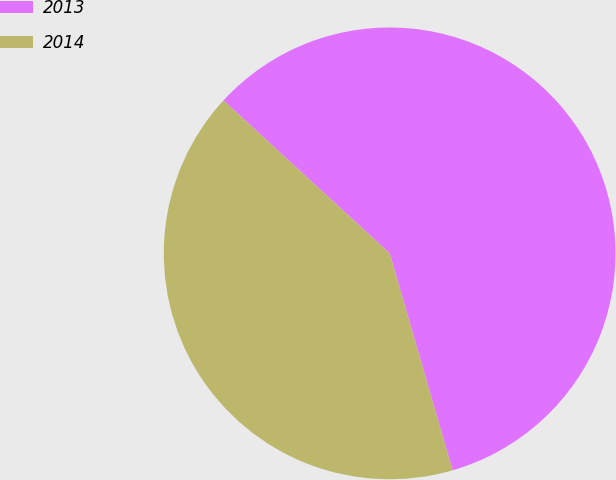Convert chart to OTSL. <chart><loc_0><loc_0><loc_500><loc_500><pie_chart><fcel>2013<fcel>2014<nl><fcel>58.67%<fcel>41.33%<nl></chart> 